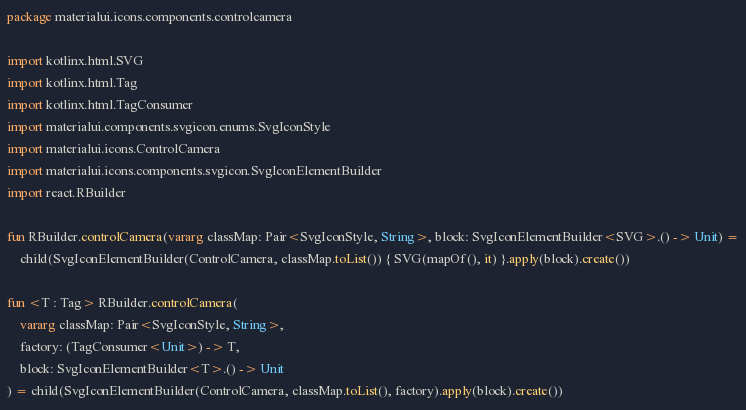<code> <loc_0><loc_0><loc_500><loc_500><_Kotlin_>package materialui.icons.components.controlcamera

import kotlinx.html.SVG
import kotlinx.html.Tag
import kotlinx.html.TagConsumer
import materialui.components.svgicon.enums.SvgIconStyle
import materialui.icons.ControlCamera
import materialui.icons.components.svgicon.SvgIconElementBuilder
import react.RBuilder

fun RBuilder.controlCamera(vararg classMap: Pair<SvgIconStyle, String>, block: SvgIconElementBuilder<SVG>.() -> Unit) =
    child(SvgIconElementBuilder(ControlCamera, classMap.toList()) { SVG(mapOf(), it) }.apply(block).create())

fun <T : Tag> RBuilder.controlCamera(
    vararg classMap: Pair<SvgIconStyle, String>,
    factory: (TagConsumer<Unit>) -> T,
    block: SvgIconElementBuilder<T>.() -> Unit
) = child(SvgIconElementBuilder(ControlCamera, classMap.toList(), factory).apply(block).create())
</code> 